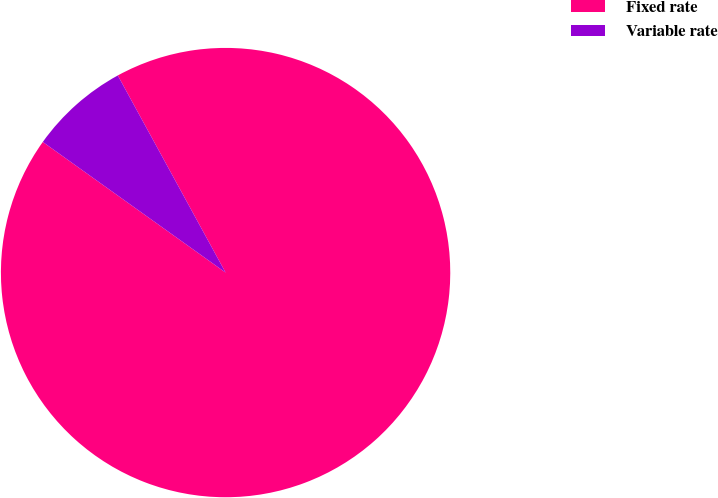Convert chart. <chart><loc_0><loc_0><loc_500><loc_500><pie_chart><fcel>Fixed rate<fcel>Variable rate<nl><fcel>92.84%<fcel>7.16%<nl></chart> 